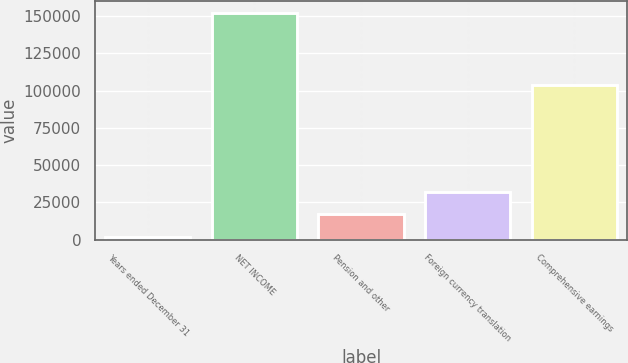Convert chart to OTSL. <chart><loc_0><loc_0><loc_500><loc_500><bar_chart><fcel>Years ended December 31<fcel>NET INCOME<fcel>Pension and other<fcel>Foreign currency translation<fcel>Comprehensive earnings<nl><fcel>2015<fcel>152149<fcel>17028.4<fcel>32041.8<fcel>103947<nl></chart> 